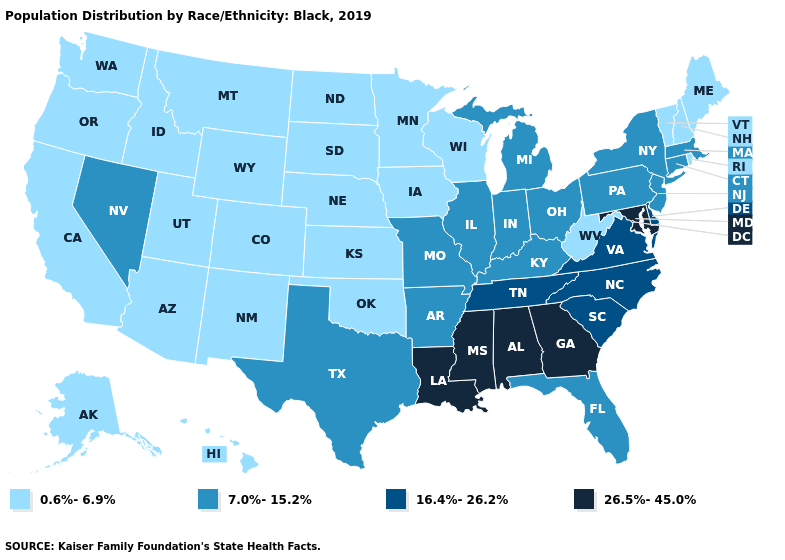What is the highest value in the USA?
Be succinct. 26.5%-45.0%. What is the value of Massachusetts?
Short answer required. 7.0%-15.2%. Does Tennessee have the lowest value in the USA?
Answer briefly. No. Name the states that have a value in the range 16.4%-26.2%?
Write a very short answer. Delaware, North Carolina, South Carolina, Tennessee, Virginia. Among the states that border Michigan , which have the highest value?
Be succinct. Indiana, Ohio. Name the states that have a value in the range 0.6%-6.9%?
Be succinct. Alaska, Arizona, California, Colorado, Hawaii, Idaho, Iowa, Kansas, Maine, Minnesota, Montana, Nebraska, New Hampshire, New Mexico, North Dakota, Oklahoma, Oregon, Rhode Island, South Dakota, Utah, Vermont, Washington, West Virginia, Wisconsin, Wyoming. Name the states that have a value in the range 7.0%-15.2%?
Quick response, please. Arkansas, Connecticut, Florida, Illinois, Indiana, Kentucky, Massachusetts, Michigan, Missouri, Nevada, New Jersey, New York, Ohio, Pennsylvania, Texas. Does New Hampshire have a higher value than Kentucky?
Concise answer only. No. What is the highest value in states that border New Jersey?
Write a very short answer. 16.4%-26.2%. What is the lowest value in the USA?
Answer briefly. 0.6%-6.9%. Does Iowa have a lower value than Alabama?
Answer briefly. Yes. Name the states that have a value in the range 26.5%-45.0%?
Quick response, please. Alabama, Georgia, Louisiana, Maryland, Mississippi. How many symbols are there in the legend?
Answer briefly. 4. What is the value of Indiana?
Give a very brief answer. 7.0%-15.2%. Which states have the lowest value in the West?
Give a very brief answer. Alaska, Arizona, California, Colorado, Hawaii, Idaho, Montana, New Mexico, Oregon, Utah, Washington, Wyoming. 